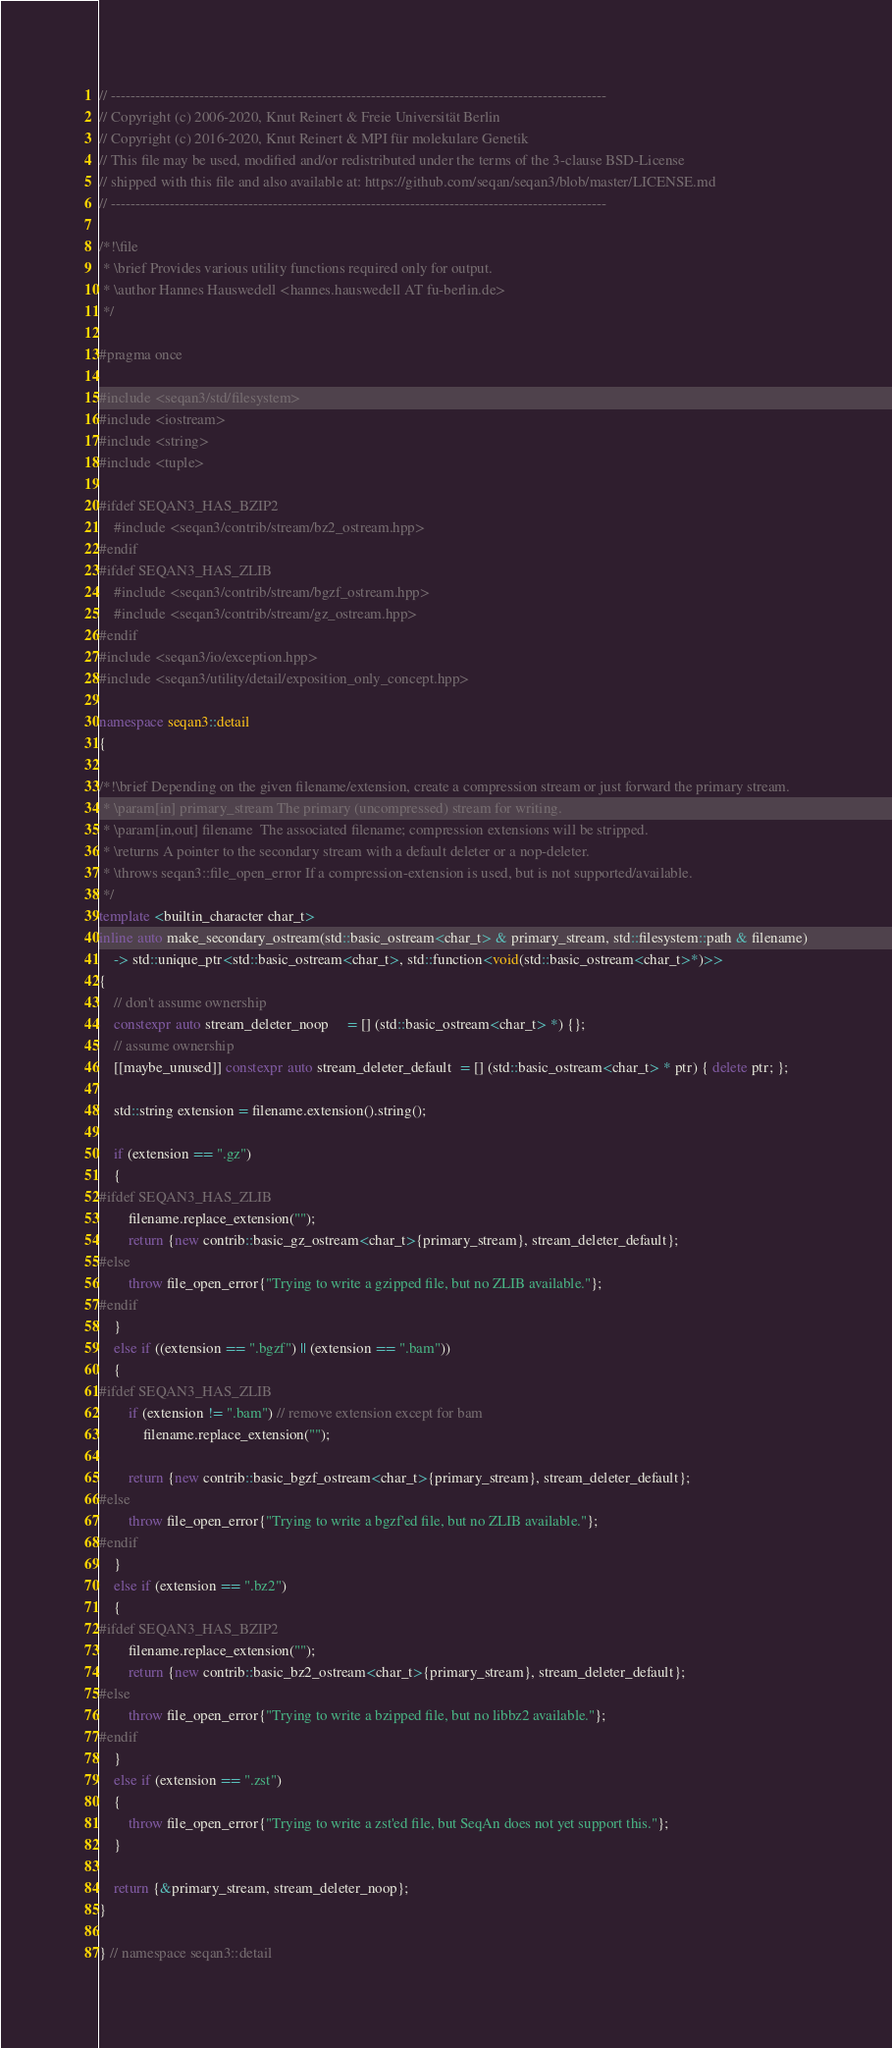Convert code to text. <code><loc_0><loc_0><loc_500><loc_500><_C++_>// -----------------------------------------------------------------------------------------------------
// Copyright (c) 2006-2020, Knut Reinert & Freie Universität Berlin
// Copyright (c) 2016-2020, Knut Reinert & MPI für molekulare Genetik
// This file may be used, modified and/or redistributed under the terms of the 3-clause BSD-License
// shipped with this file and also available at: https://github.com/seqan/seqan3/blob/master/LICENSE.md
// -----------------------------------------------------------------------------------------------------

/*!\file
 * \brief Provides various utility functions required only for output.
 * \author Hannes Hauswedell <hannes.hauswedell AT fu-berlin.de>
 */

#pragma once

#include <seqan3/std/filesystem>
#include <iostream>
#include <string>
#include <tuple>

#ifdef SEQAN3_HAS_BZIP2
    #include <seqan3/contrib/stream/bz2_ostream.hpp>
#endif
#ifdef SEQAN3_HAS_ZLIB
    #include <seqan3/contrib/stream/bgzf_ostream.hpp>
    #include <seqan3/contrib/stream/gz_ostream.hpp>
#endif
#include <seqan3/io/exception.hpp>
#include <seqan3/utility/detail/exposition_only_concept.hpp>

namespace seqan3::detail
{

/*!\brief Depending on the given filename/extension, create a compression stream or just forward the primary stream.
 * \param[in] primary_stream The primary (uncompressed) stream for writing.
 * \param[in,out] filename  The associated filename; compression extensions will be stripped.
 * \returns A pointer to the secondary stream with a default deleter or a nop-deleter.
 * \throws seqan3::file_open_error If a compression-extension is used, but is not supported/available.
 */
template <builtin_character char_t>
inline auto make_secondary_ostream(std::basic_ostream<char_t> & primary_stream, std::filesystem::path & filename)
    -> std::unique_ptr<std::basic_ostream<char_t>, std::function<void(std::basic_ostream<char_t>*)>>
{
    // don't assume ownership
    constexpr auto stream_deleter_noop     = [] (std::basic_ostream<char_t> *) {};
    // assume ownership
    [[maybe_unused]] constexpr auto stream_deleter_default  = [] (std::basic_ostream<char_t> * ptr) { delete ptr; };

    std::string extension = filename.extension().string();

    if (extension == ".gz")
    {
#ifdef SEQAN3_HAS_ZLIB
        filename.replace_extension("");
        return {new contrib::basic_gz_ostream<char_t>{primary_stream}, stream_deleter_default};
#else
        throw file_open_error{"Trying to write a gzipped file, but no ZLIB available."};
#endif
    }
    else if ((extension == ".bgzf") || (extension == ".bam"))
    {
#ifdef SEQAN3_HAS_ZLIB
        if (extension != ".bam") // remove extension except for bam
            filename.replace_extension("");

        return {new contrib::basic_bgzf_ostream<char_t>{primary_stream}, stream_deleter_default};
#else
        throw file_open_error{"Trying to write a bgzf'ed file, but no ZLIB available."};
#endif
    }
    else if (extension == ".bz2")
    {
#ifdef SEQAN3_HAS_BZIP2
        filename.replace_extension("");
        return {new contrib::basic_bz2_ostream<char_t>{primary_stream}, stream_deleter_default};
#else
        throw file_open_error{"Trying to write a bzipped file, but no libbz2 available."};
#endif
    }
    else if (extension == ".zst")
    {
        throw file_open_error{"Trying to write a zst'ed file, but SeqAn does not yet support this."};
    }

    return {&primary_stream, stream_deleter_noop};
}

} // namespace seqan3::detail
</code> 